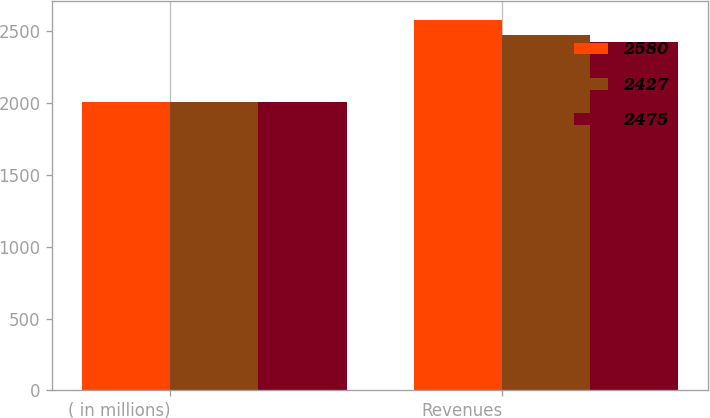Convert chart to OTSL. <chart><loc_0><loc_0><loc_500><loc_500><stacked_bar_chart><ecel><fcel>( in millions)<fcel>Revenues<nl><fcel>2580<fcel>2007<fcel>2580<nl><fcel>2427<fcel>2006<fcel>2475<nl><fcel>2475<fcel>2005<fcel>2427<nl></chart> 